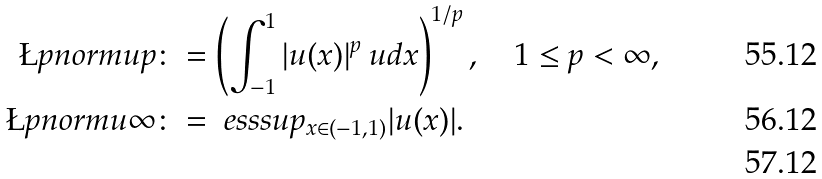Convert formula to latex. <formula><loc_0><loc_0><loc_500><loc_500>\L p n o r m { u } { p } & \colon = \left ( \int ^ { 1 } _ { - 1 } | u ( x ) | ^ { p } \ u d x \right ) ^ { 1 / p } , \quad 1 \leq p < \infty , \\ \L p n o r m { u } { \infty } & \colon = \ e s s s u p _ { x \in ( - 1 , 1 ) } | u ( x ) | . \\</formula> 